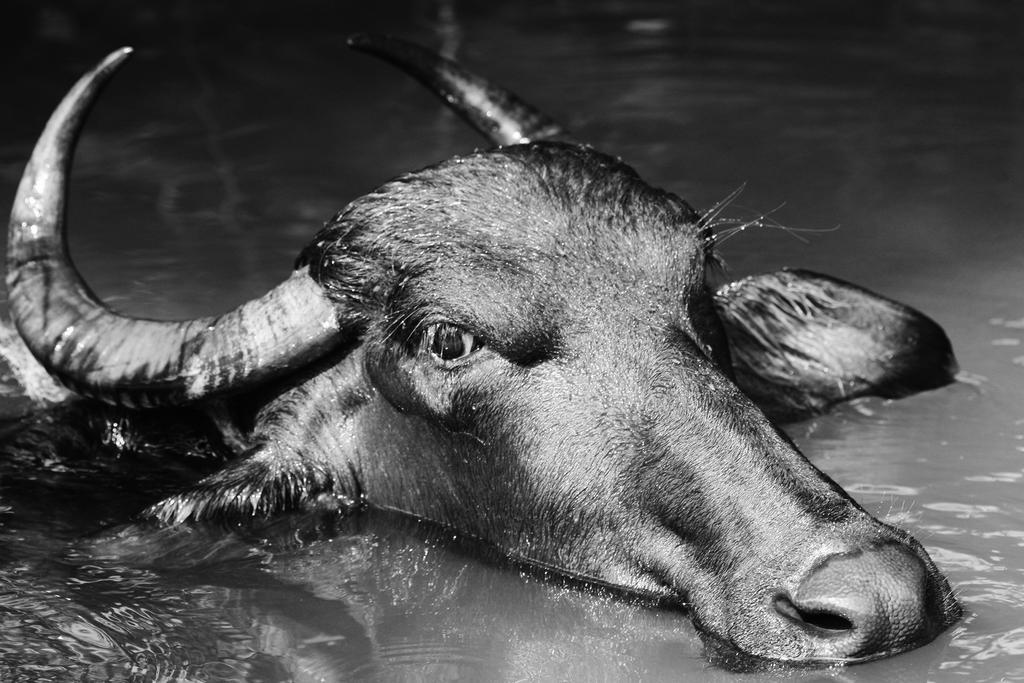Please provide a concise description of this image. This image consists of a buffalo in black color. It is in the water. At the bottom, there is water. 